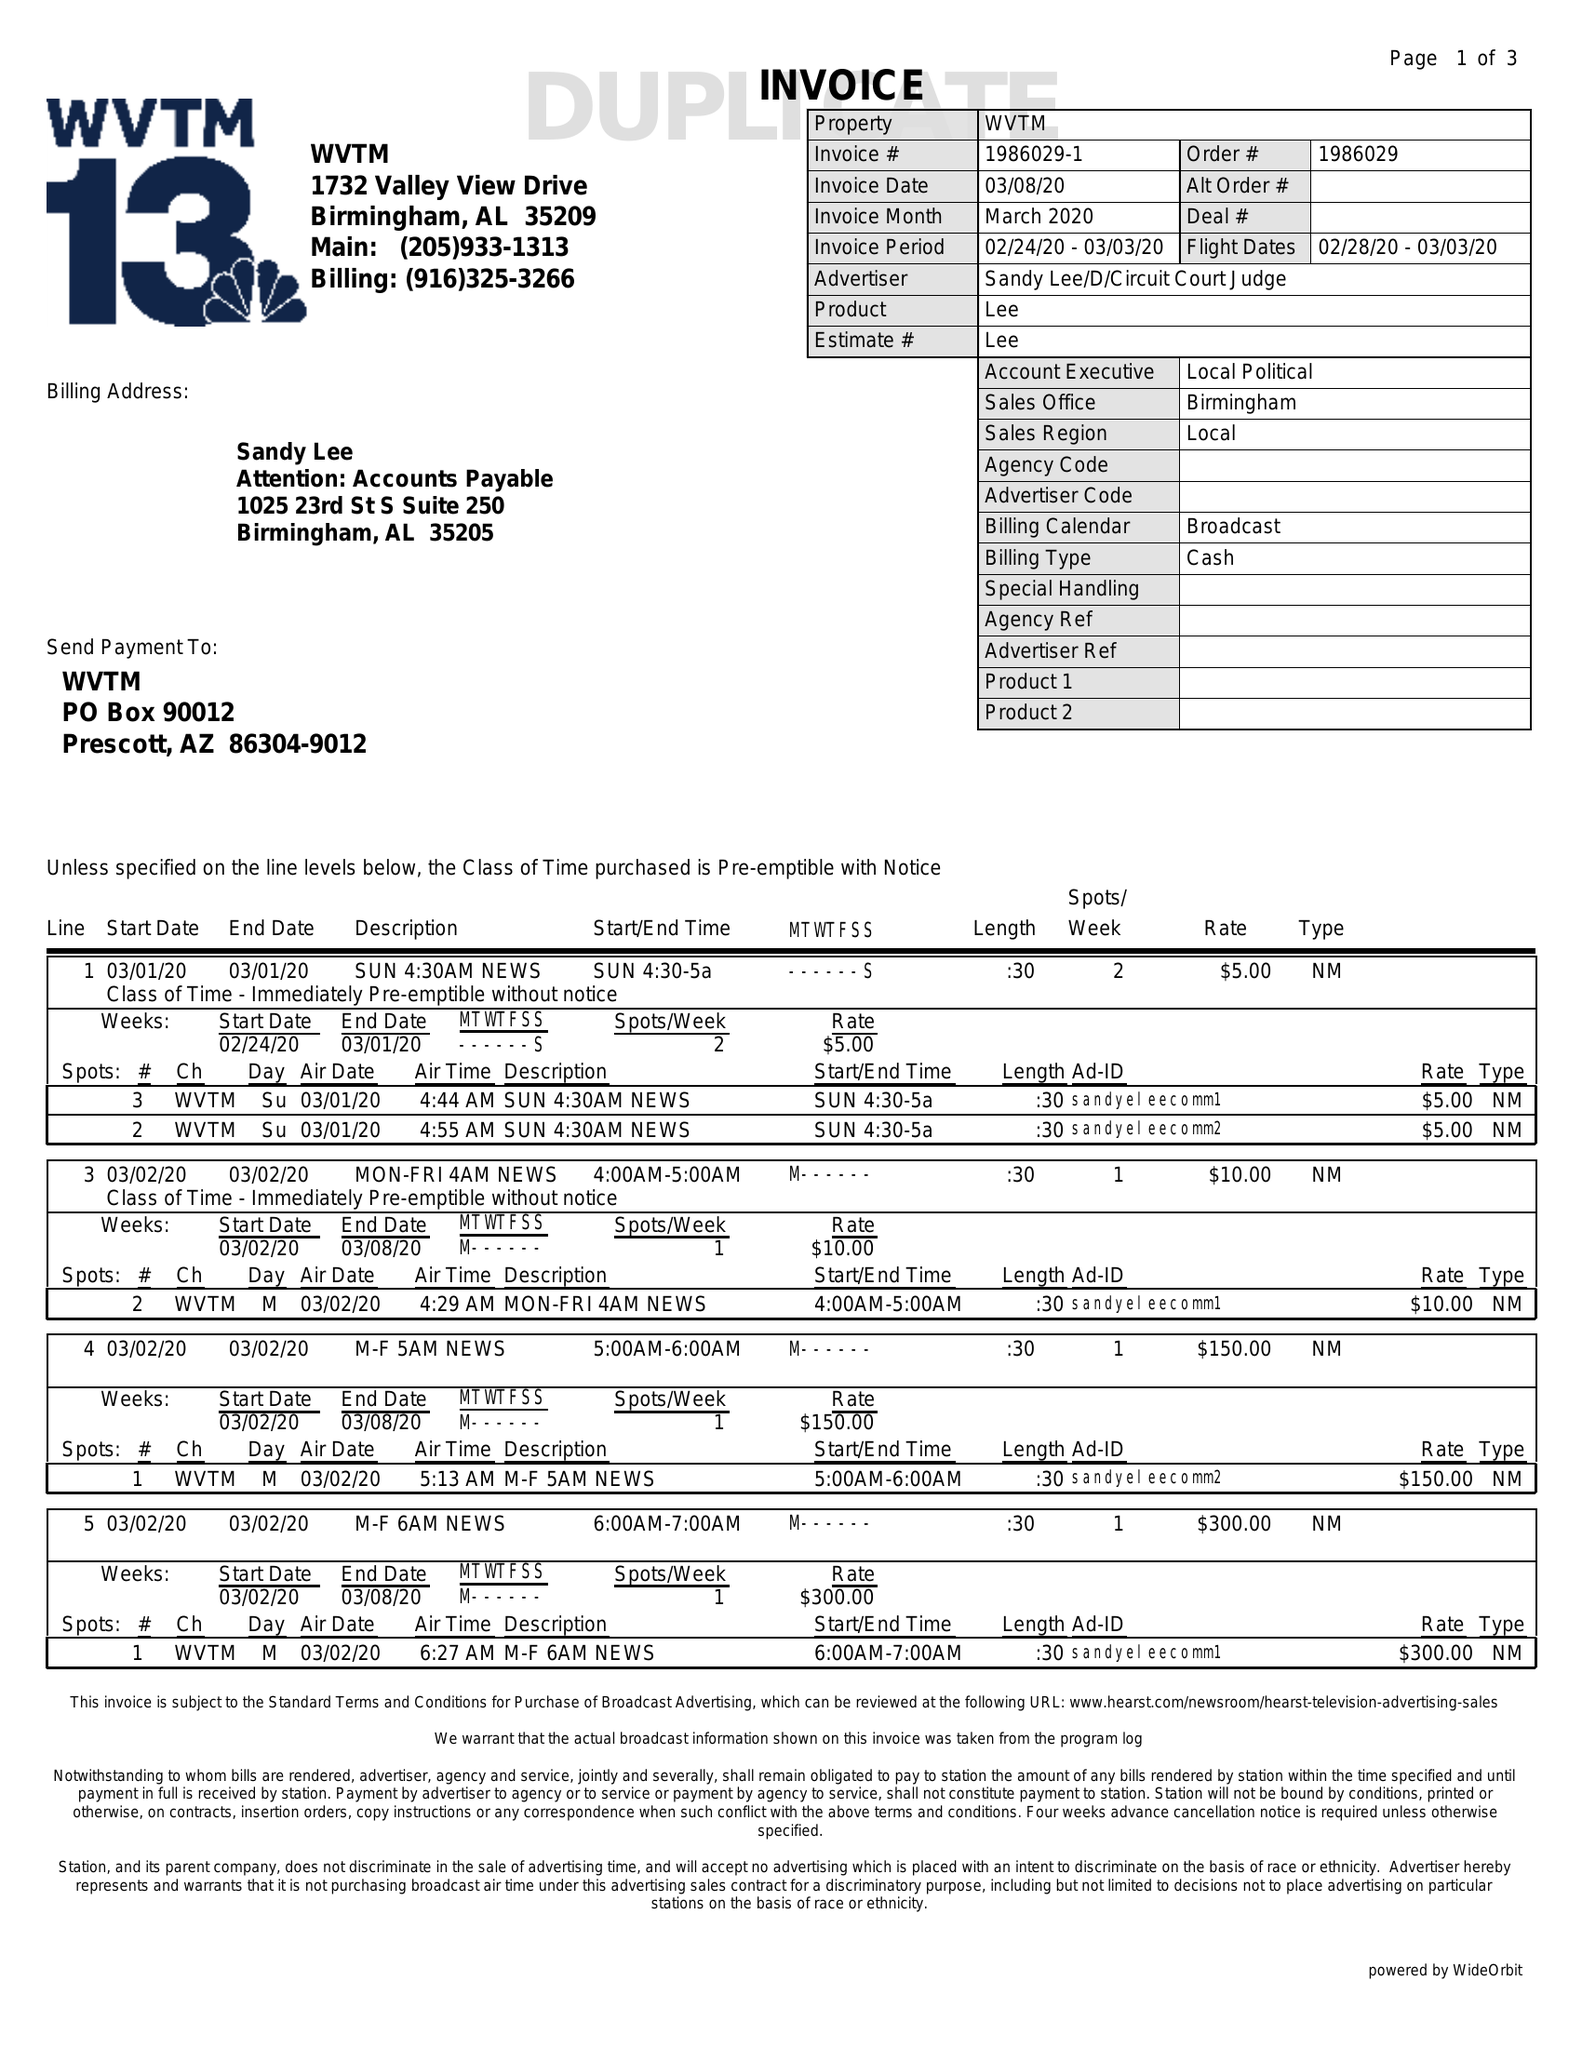What is the value for the contract_num?
Answer the question using a single word or phrase. 1986029 